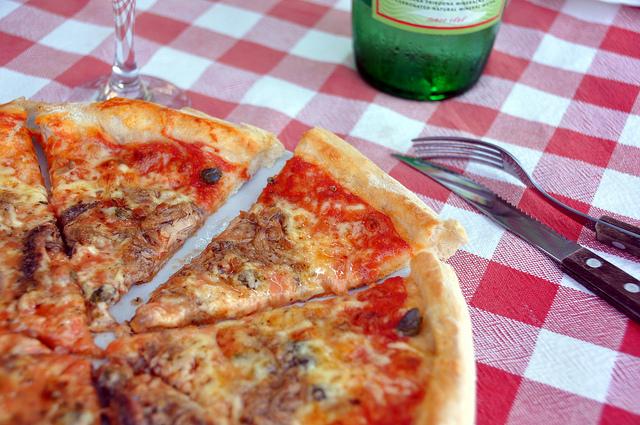What eating utensils are needed for this food?
Answer briefly. None. Is there a cup of water?
Write a very short answer. No. Is this food eaten with a fork?
Short answer required. No. What color is the bottle?
Write a very short answer. Green. What pattern is the tablecloth?
Keep it brief. Checkered. What color is the tablecloth?
Give a very brief answer. Red and white. 